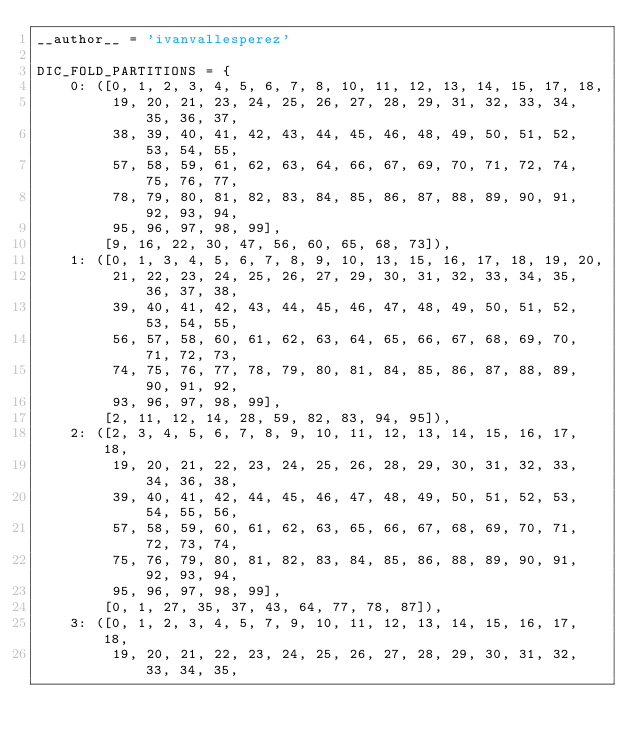Convert code to text. <code><loc_0><loc_0><loc_500><loc_500><_Python_>__author__ = 'ivanvallesperez'

DIC_FOLD_PARTITIONS = {
    0: ([0, 1, 2, 3, 4, 5, 6, 7, 8, 10, 11, 12, 13, 14, 15, 17, 18,
         19, 20, 21, 23, 24, 25, 26, 27, 28, 29, 31, 32, 33, 34, 35, 36, 37,
         38, 39, 40, 41, 42, 43, 44, 45, 46, 48, 49, 50, 51, 52, 53, 54, 55,
         57, 58, 59, 61, 62, 63, 64, 66, 67, 69, 70, 71, 72, 74, 75, 76, 77,
         78, 79, 80, 81, 82, 83, 84, 85, 86, 87, 88, 89, 90, 91, 92, 93, 94,
         95, 96, 97, 98, 99],
        [9, 16, 22, 30, 47, 56, 60, 65, 68, 73]),
    1: ([0, 1, 3, 4, 5, 6, 7, 8, 9, 10, 13, 15, 16, 17, 18, 19, 20,
         21, 22, 23, 24, 25, 26, 27, 29, 30, 31, 32, 33, 34, 35, 36, 37, 38,
         39, 40, 41, 42, 43, 44, 45, 46, 47, 48, 49, 50, 51, 52, 53, 54, 55,
         56, 57, 58, 60, 61, 62, 63, 64, 65, 66, 67, 68, 69, 70, 71, 72, 73,
         74, 75, 76, 77, 78, 79, 80, 81, 84, 85, 86, 87, 88, 89, 90, 91, 92,
         93, 96, 97, 98, 99],
        [2, 11, 12, 14, 28, 59, 82, 83, 94, 95]),
    2: ([2, 3, 4, 5, 6, 7, 8, 9, 10, 11, 12, 13, 14, 15, 16, 17, 18,
         19, 20, 21, 22, 23, 24, 25, 26, 28, 29, 30, 31, 32, 33, 34, 36, 38,
         39, 40, 41, 42, 44, 45, 46, 47, 48, 49, 50, 51, 52, 53, 54, 55, 56,
         57, 58, 59, 60, 61, 62, 63, 65, 66, 67, 68, 69, 70, 71, 72, 73, 74,
         75, 76, 79, 80, 81, 82, 83, 84, 85, 86, 88, 89, 90, 91, 92, 93, 94,
         95, 96, 97, 98, 99],
        [0, 1, 27, 35, 37, 43, 64, 77, 78, 87]),
    3: ([0, 1, 2, 3, 4, 5, 7, 9, 10, 11, 12, 13, 14, 15, 16, 17, 18,
         19, 20, 21, 22, 23, 24, 25, 26, 27, 28, 29, 30, 31, 32, 33, 34, 35,</code> 